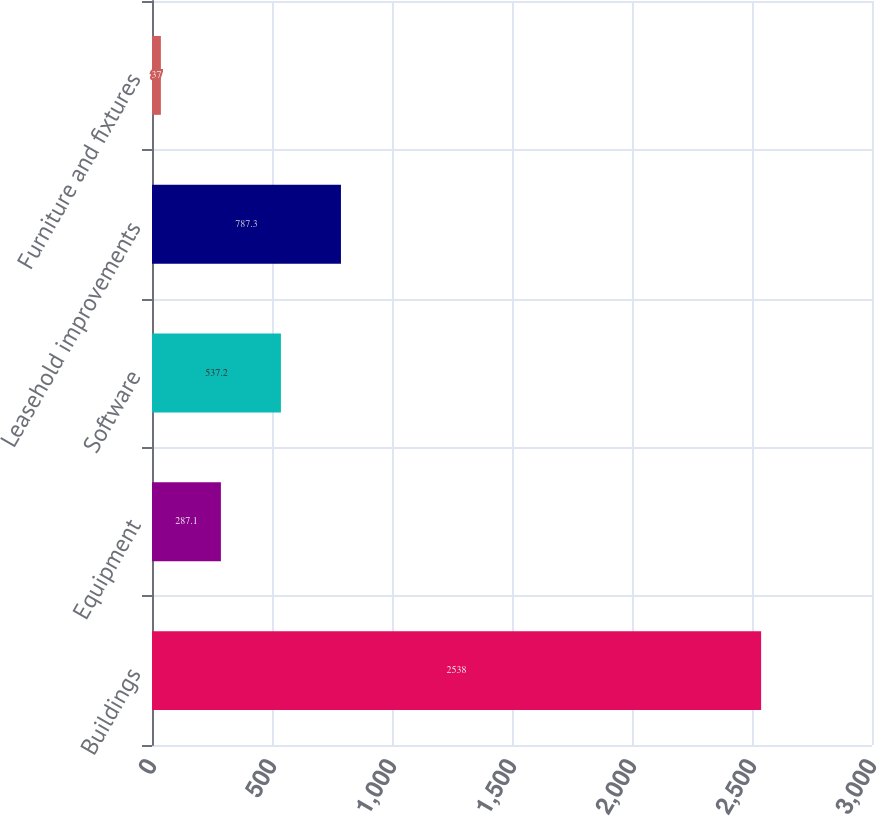<chart> <loc_0><loc_0><loc_500><loc_500><bar_chart><fcel>Buildings<fcel>Equipment<fcel>Software<fcel>Leasehold improvements<fcel>Furniture and fixtures<nl><fcel>2538<fcel>287.1<fcel>537.2<fcel>787.3<fcel>37<nl></chart> 